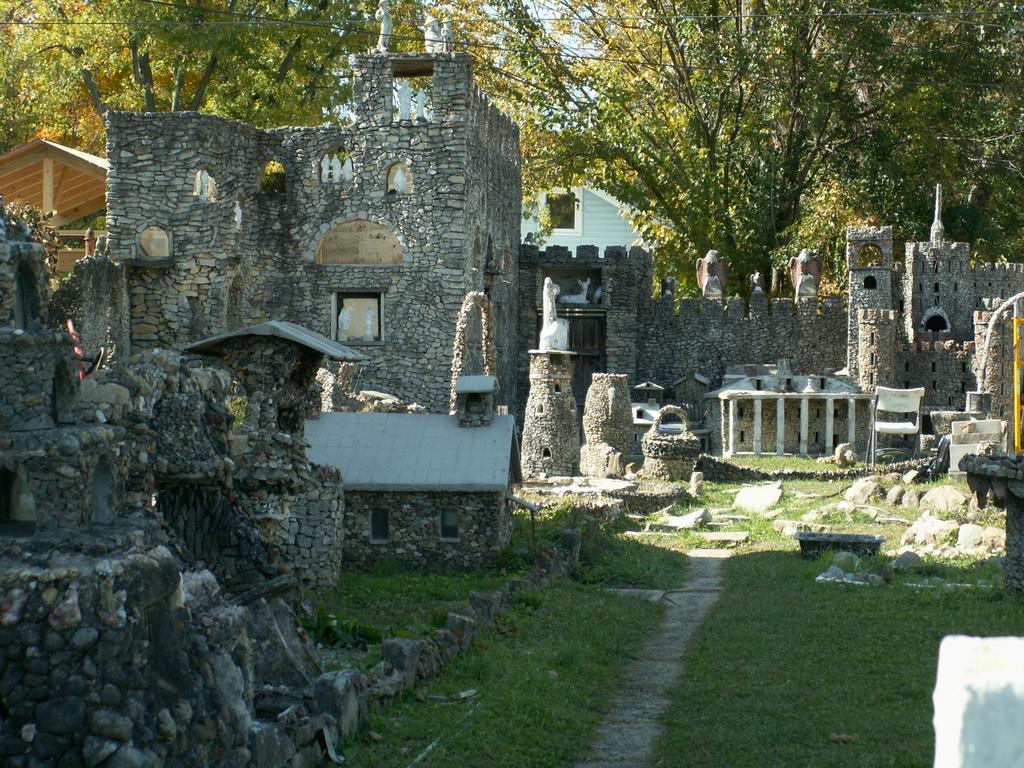Please provide a concise description of this image. In the picture we can see some historical constructions on the grass surface and behind it, we can see a shed and behind it, we can see trees and behind it, we can see a house and top of it we can see a part of the sky. 